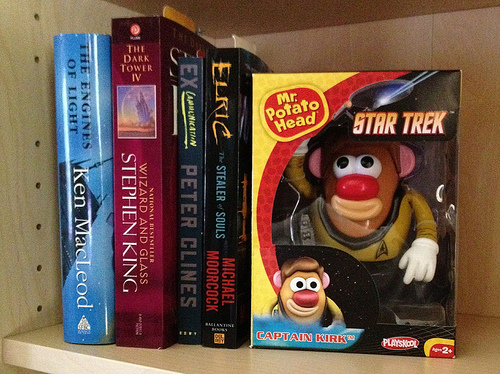<image>
Is there a book on the shelf? Yes. Looking at the image, I can see the book is positioned on top of the shelf, with the shelf providing support. Is the toy behind the book? No. The toy is not behind the book. From this viewpoint, the toy appears to be positioned elsewhere in the scene. 